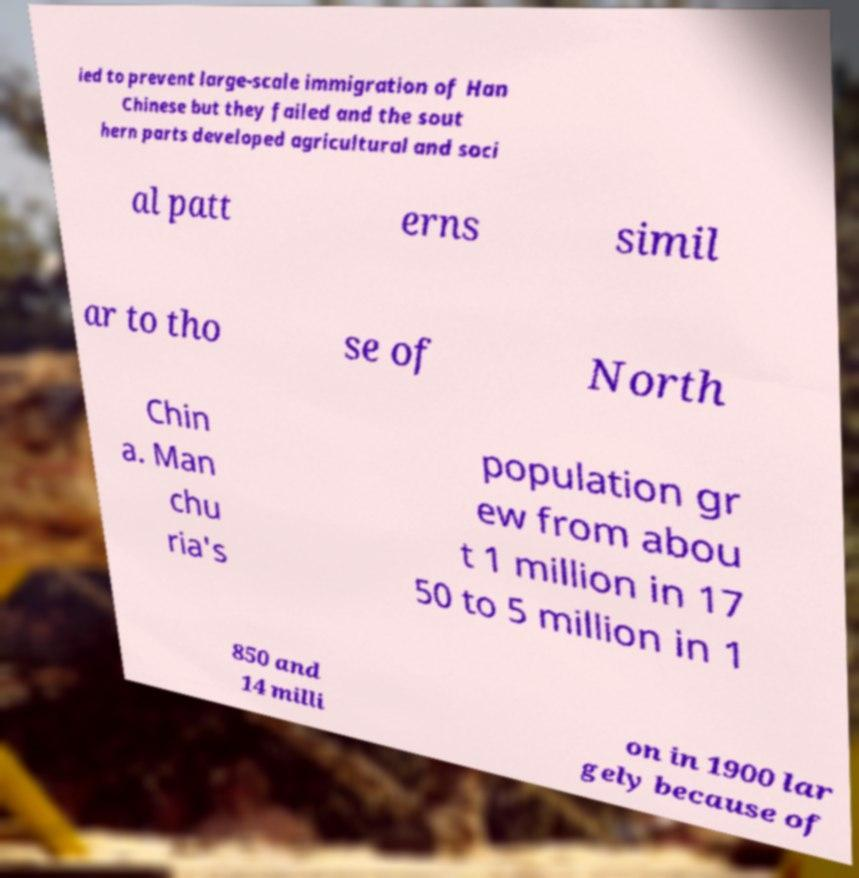For documentation purposes, I need the text within this image transcribed. Could you provide that? ied to prevent large-scale immigration of Han Chinese but they failed and the sout hern parts developed agricultural and soci al patt erns simil ar to tho se of North Chin a. Man chu ria's population gr ew from abou t 1 million in 17 50 to 5 million in 1 850 and 14 milli on in 1900 lar gely because of 